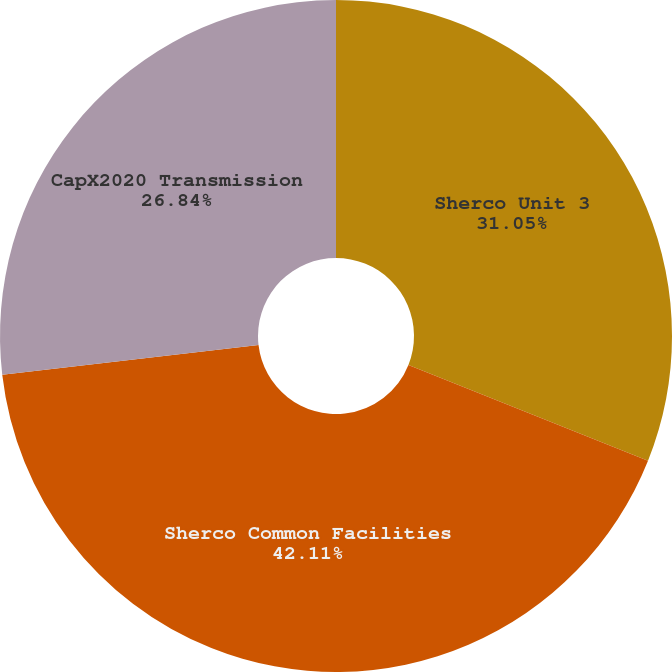Convert chart. <chart><loc_0><loc_0><loc_500><loc_500><pie_chart><fcel>Sherco Unit 3<fcel>Sherco Common Facilities<fcel>CapX2020 Transmission<nl><fcel>31.05%<fcel>42.11%<fcel>26.84%<nl></chart> 